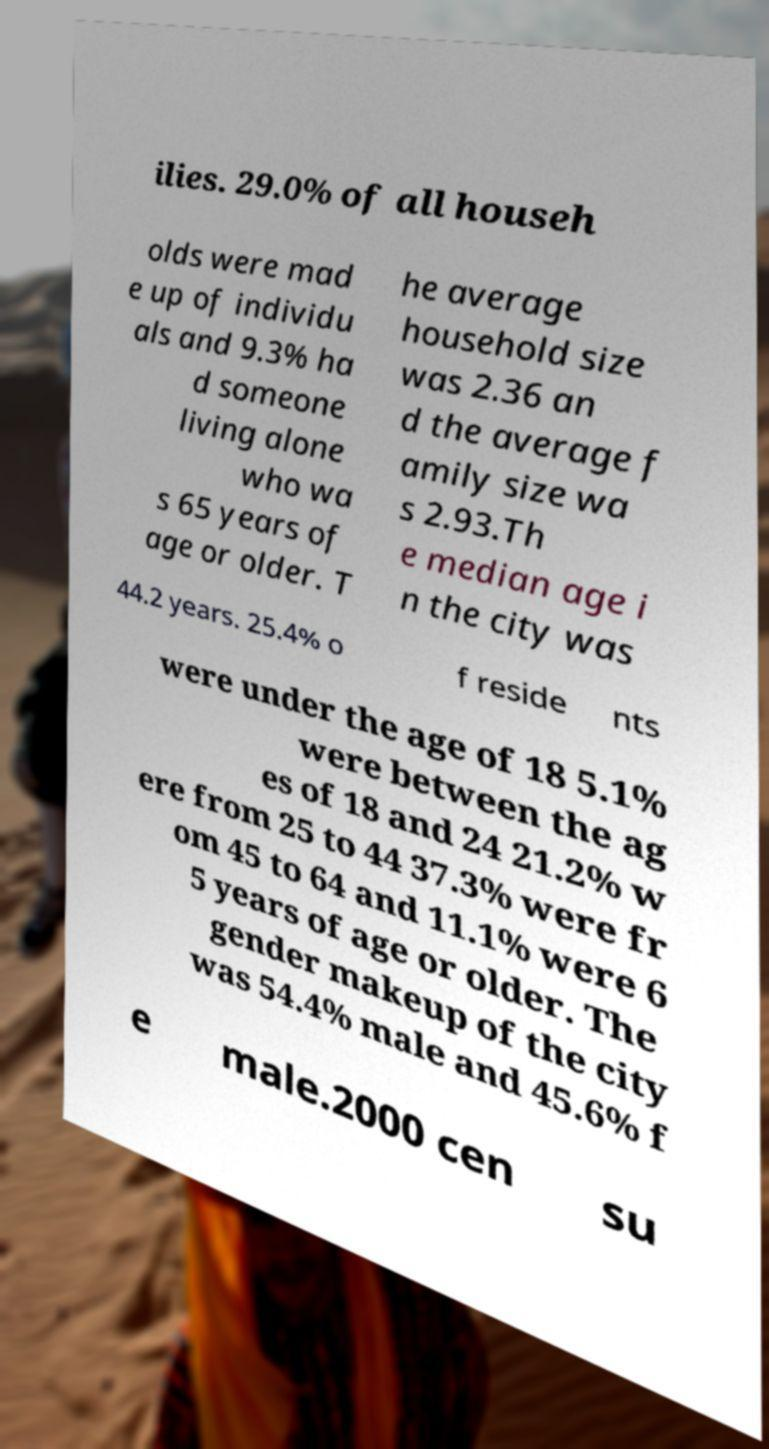There's text embedded in this image that I need extracted. Can you transcribe it verbatim? ilies. 29.0% of all househ olds were mad e up of individu als and 9.3% ha d someone living alone who wa s 65 years of age or older. T he average household size was 2.36 an d the average f amily size wa s 2.93.Th e median age i n the city was 44.2 years. 25.4% o f reside nts were under the age of 18 5.1% were between the ag es of 18 and 24 21.2% w ere from 25 to 44 37.3% were fr om 45 to 64 and 11.1% were 6 5 years of age or older. The gender makeup of the city was 54.4% male and 45.6% f e male.2000 cen su 